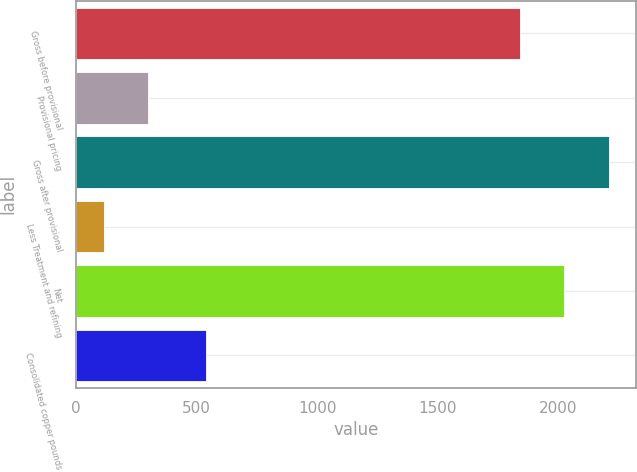Convert chart to OTSL. <chart><loc_0><loc_0><loc_500><loc_500><bar_chart><fcel>Gross before provisional<fcel>Provisional pricing<fcel>Gross after provisional<fcel>Less Treatment and refining<fcel>Net<fcel>Consolidated copper pounds<nl><fcel>1842<fcel>298.8<fcel>2211.6<fcel>114<fcel>2026.8<fcel>539<nl></chart> 